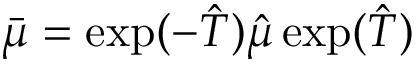<formula> <loc_0><loc_0><loc_500><loc_500>\bar { \mu } = \exp ( - \hat { T } ) \hat { \mu } \exp ( \hat { T } )</formula> 